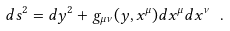<formula> <loc_0><loc_0><loc_500><loc_500>d s ^ { 2 } = d y ^ { 2 } + g _ { \mu \nu } ( y , x ^ { \mu } ) d x ^ { \mu } d x ^ { \nu } \ .</formula> 